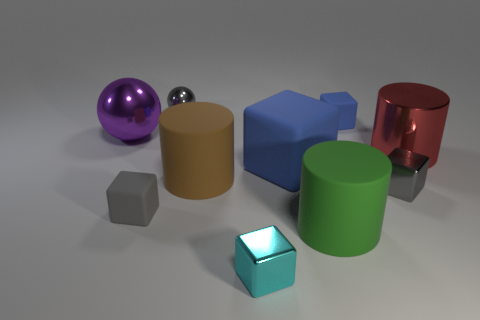Subtract 2 cubes. How many cubes are left? 3 Subtract all green cubes. Subtract all red cylinders. How many cubes are left? 5 Subtract all spheres. How many objects are left? 8 Subtract all gray metallic blocks. Subtract all big red objects. How many objects are left? 8 Add 7 cyan shiny objects. How many cyan shiny objects are left? 8 Add 2 cyan blocks. How many cyan blocks exist? 3 Subtract 0 green balls. How many objects are left? 10 